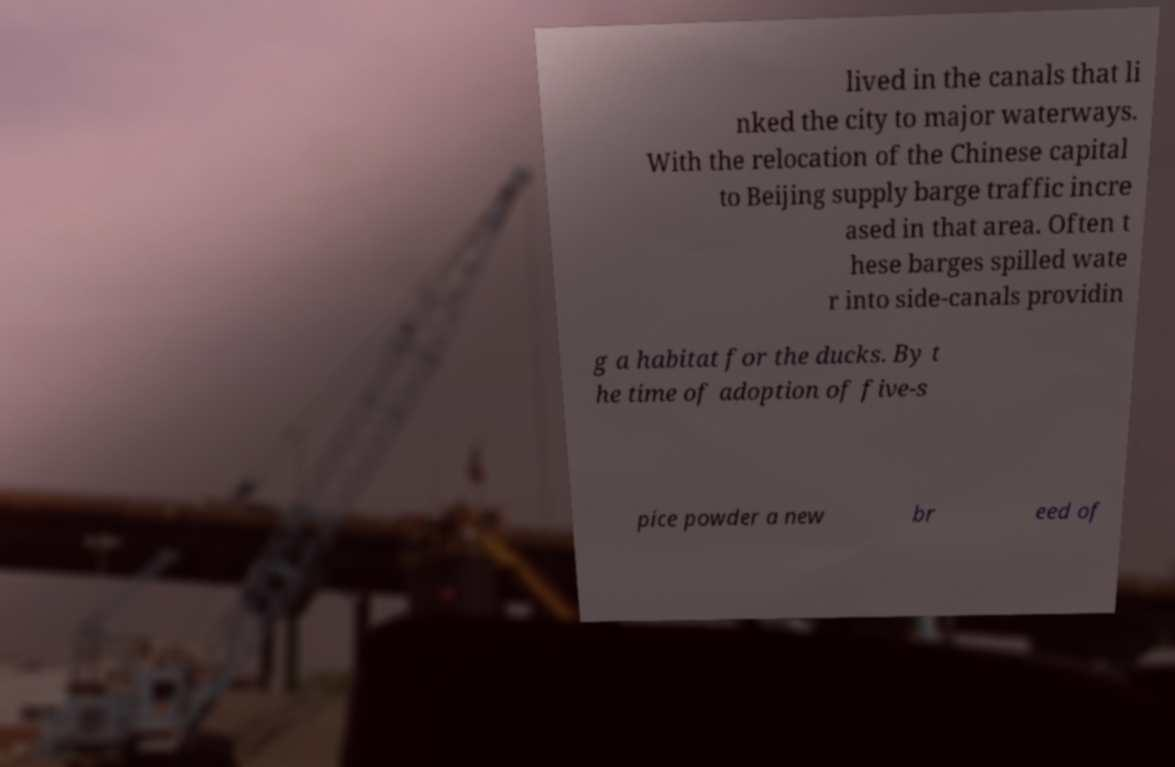Please read and relay the text visible in this image. What does it say? lived in the canals that li nked the city to major waterways. With the relocation of the Chinese capital to Beijing supply barge traffic incre ased in that area. Often t hese barges spilled wate r into side-canals providin g a habitat for the ducks. By t he time of adoption of five-s pice powder a new br eed of 